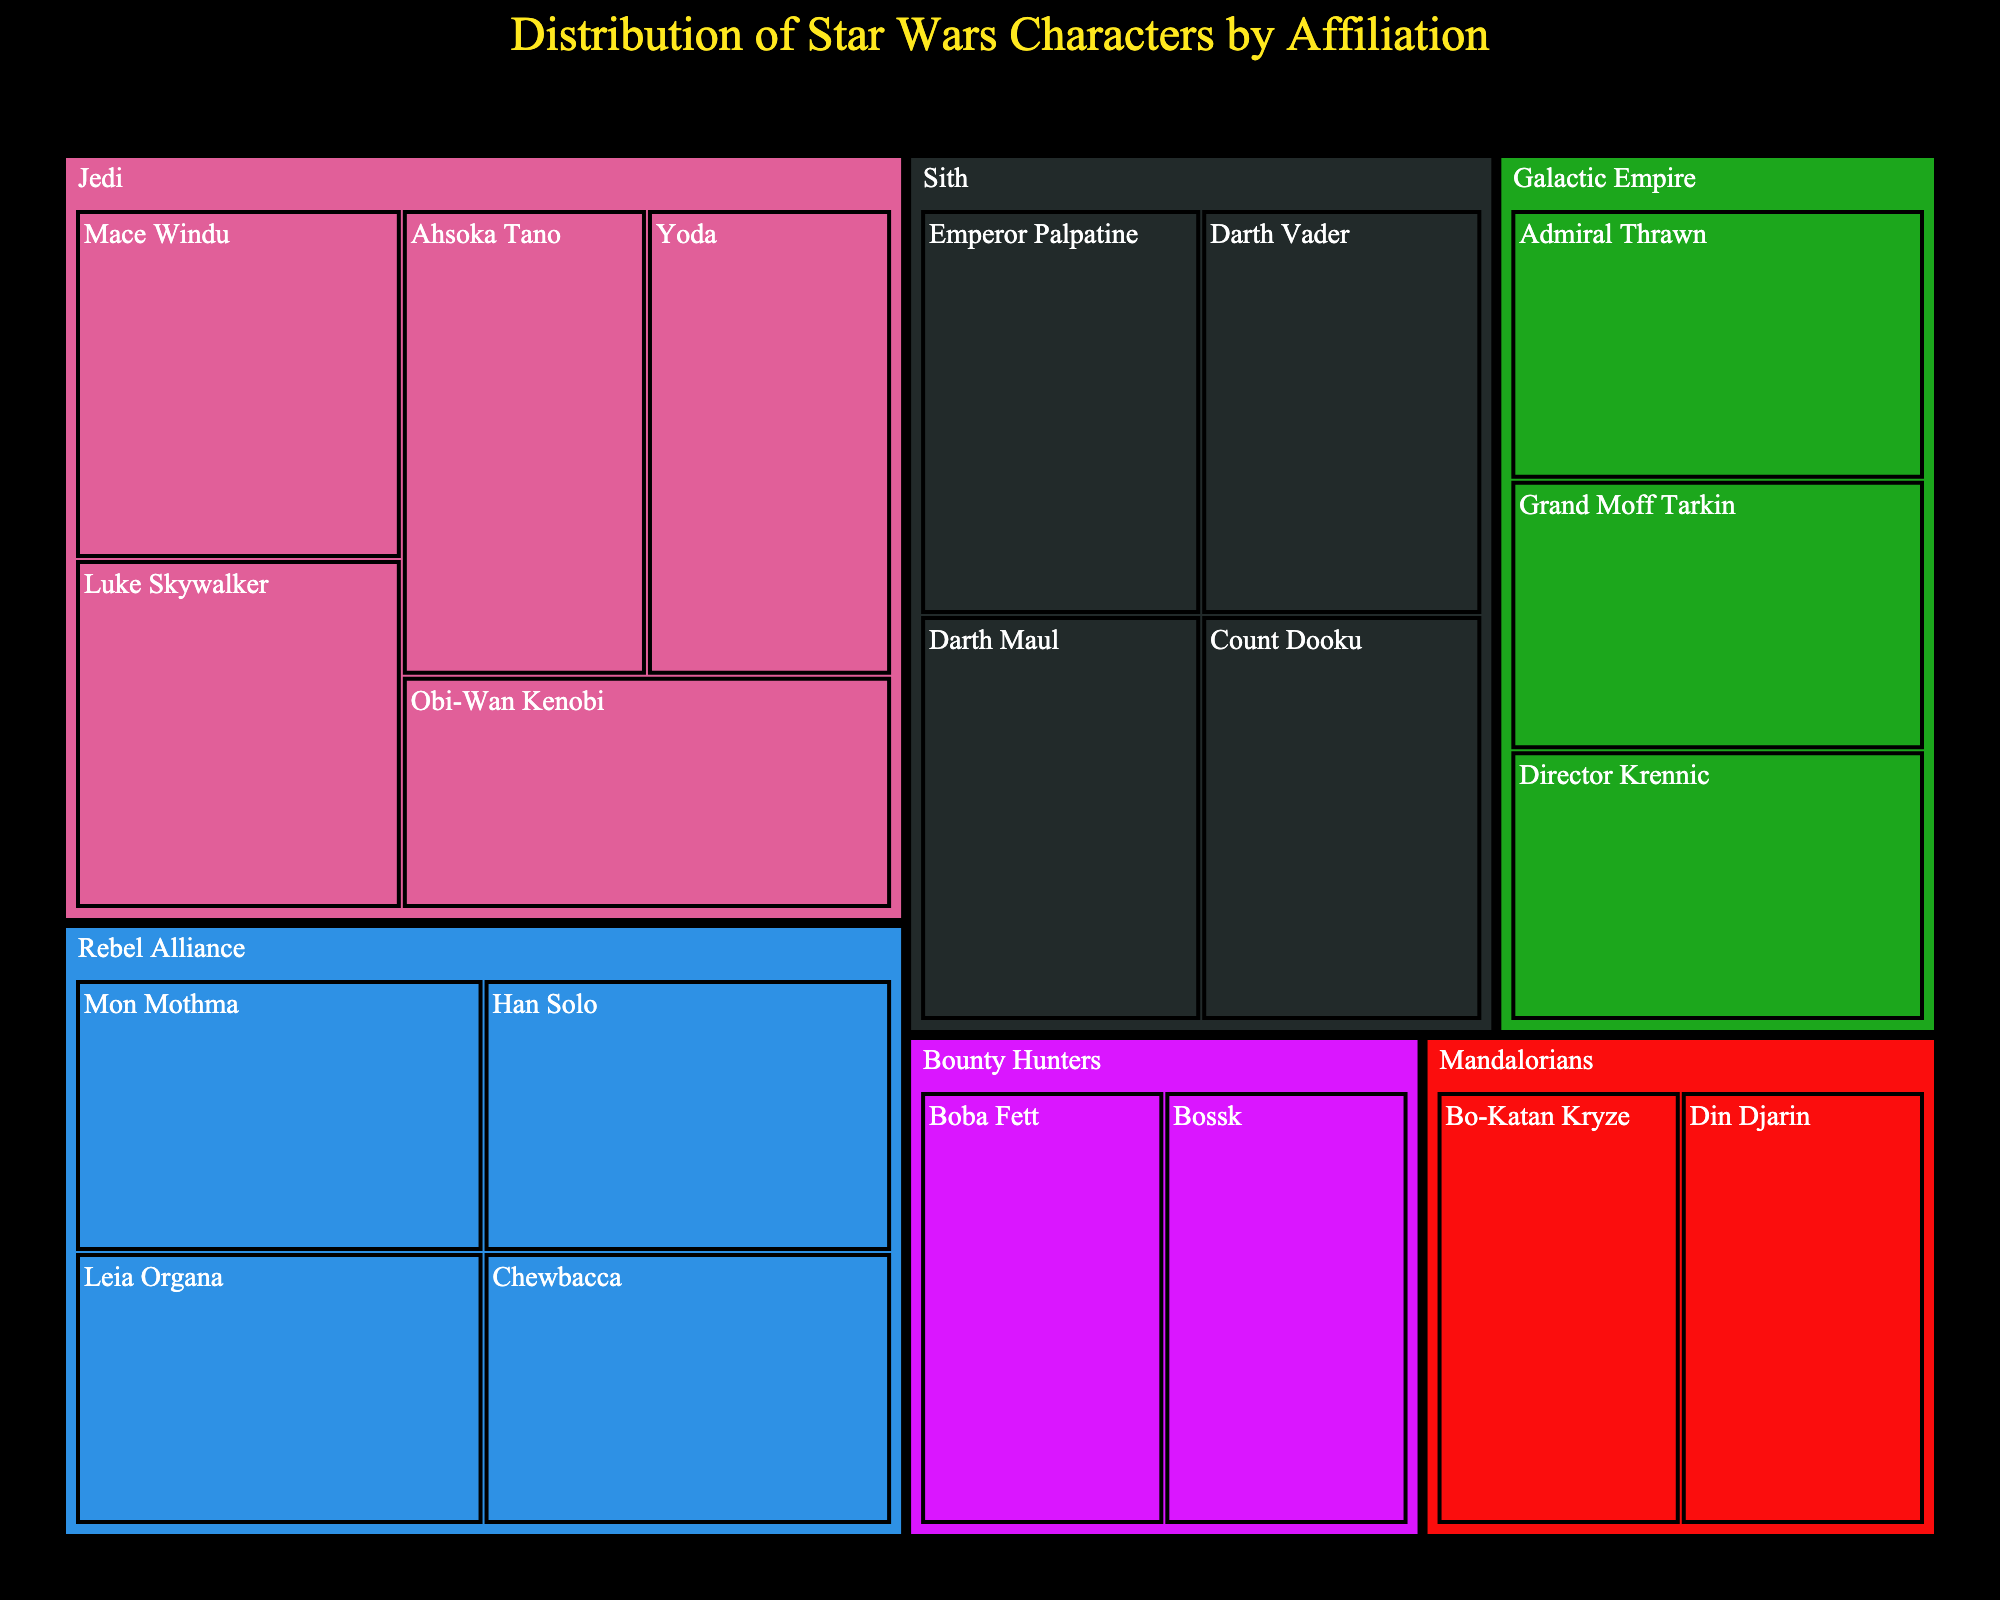What's the title of the figure? The title of the figure is usually displayed at the top and summarizes the content. In this case, it is "Distribution of Star Wars Characters by Affiliation."
Answer: Distribution of Star Wars Characters by Affiliation How many characters are affiliated with the Jedi? By looking at the section labeled "Jedi" and counting the characters underneath it, we can see there are five characters listed: Luke Skywalker, Obi-Wan Kenobi, Yoda, Ahsoka Tano, and Mace Windu.
Answer: 5 Which affiliation has the fewest characters? By comparing the number of characters in each affiliation category, we can see that both the "Mandalorians" and "Bounty Hunters" categories have only two characters each, which is the fewest.
Answer: Mandalorians and Bounty Hunters What's the total number of characters depicted in the treemap? Summing the counts of all the characters across all affiliations gives us the total number of characters. We have 5 (Jedi) + 4 (Sith) + 4 (Rebel Alliance) + 3 (Galactic Empire) + 2 (Bounty Hunters) + 2 (Mandalorians) = 20.
Answer: 20 Which affiliation has more characters, Sith or Rebel Alliance? Comparing the counts, the Sith have 4 characters (Darth Vader, Emperor Palpatine, Darth Maul, Count Dooku) and so does the Rebel Alliance (Leia Organa, Han Solo, Chewbacca, Mon Mothma). Both have the same number of characters.
Answer: They have the same number How does the number of characters in the Galactic Empire compare to those in the Jedi? The Galactic Empire has 3 characters (Grand Moff Tarkin, Admiral Thrawn, Director Krennic), while the Jedi have 5 characters. Therefore, the Galactic Empire has fewer characters than the Jedi.
Answer: The Galactic Empire has fewer characters Identify the affiliations that have fewer than 4 characters. By examining the number of characters in each affiliation, we can see the groups with fewer than 4 characters are: Bounty Hunters (2), Mandalorians (2), and Galactic Empire (3).
Answer: Bounty Hunters, Mandalorians, and Galactic Empire Which affiliation includes Han Solo? We find Han Solo under the "Rebel Alliance" section of the figure.
Answer: Rebel Alliance What's the combined number of characters in the Bounty Hunters and Mandalorians affiliations? Adding the counts of the Bounty Hunters (2 characters) and Mandalorians (2 characters) affiliations, we get a total of 4 characters.
Answer: 4 What color is typically used to represent the Jedi affiliation in the treemap? We can determine the specific color assigned to the Jedi affiliation by looking at the color-coded sections in the treemap. This information is visually outlined but may vary slightly based on different visualizations.
Answer: Varies, but often distinguishable from other groups 